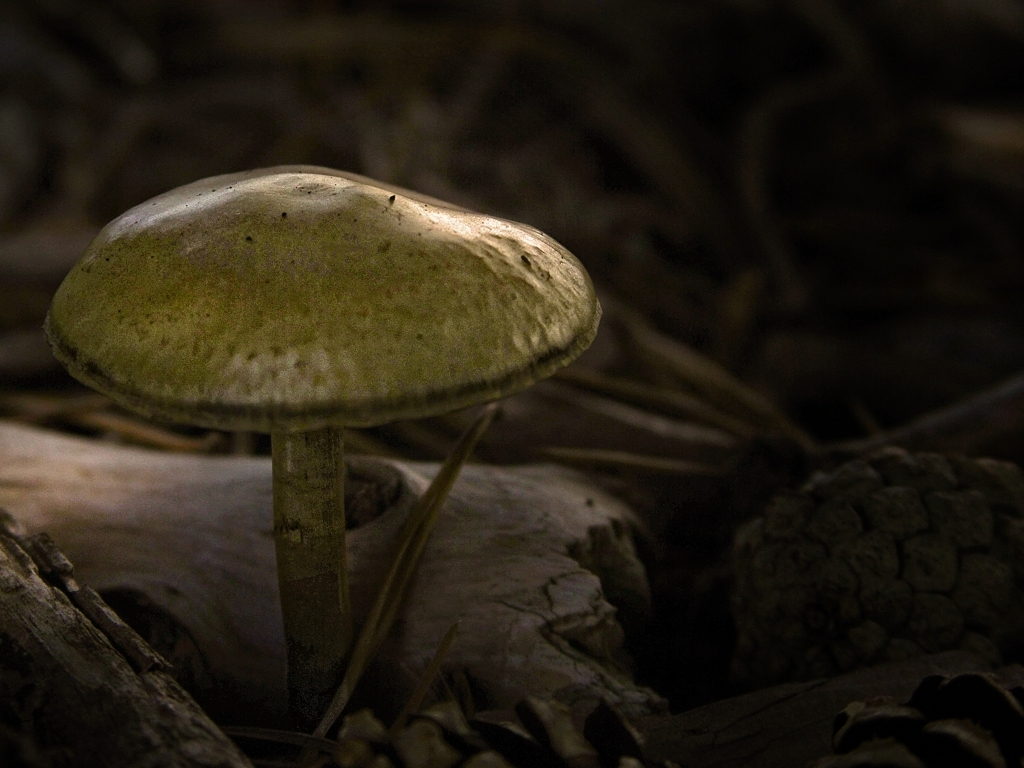Are there any quality issues with this image? The image appears to be well-composed with a clear focus on a mushroom in its natural environment. There are no apparent technical quality issues such as blurriness or overexposure, though there is a notable dark tone to the image, which may or may not be intentional. If the darkness is not desired, increasing the exposure or brightness could enhance the details in the shadowy areas. 